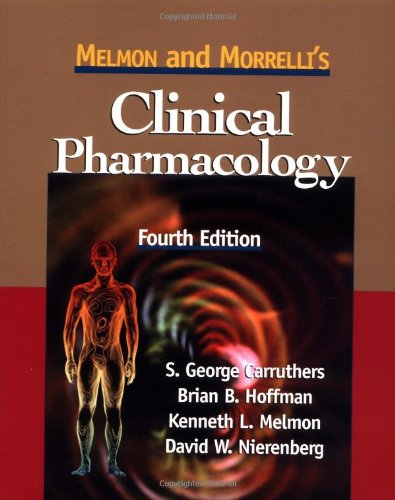What makes the fourth edition of this book different from previous editions? The fourth edition of 'Melmon and Morrelli's Clinical Pharmacology' includes updated drug information reflecting recent pharmacological discoveries and regulatory changes. It also features enhanced sections on treatment protocols and new drug classes to provide current clinical guidelines and practices. 